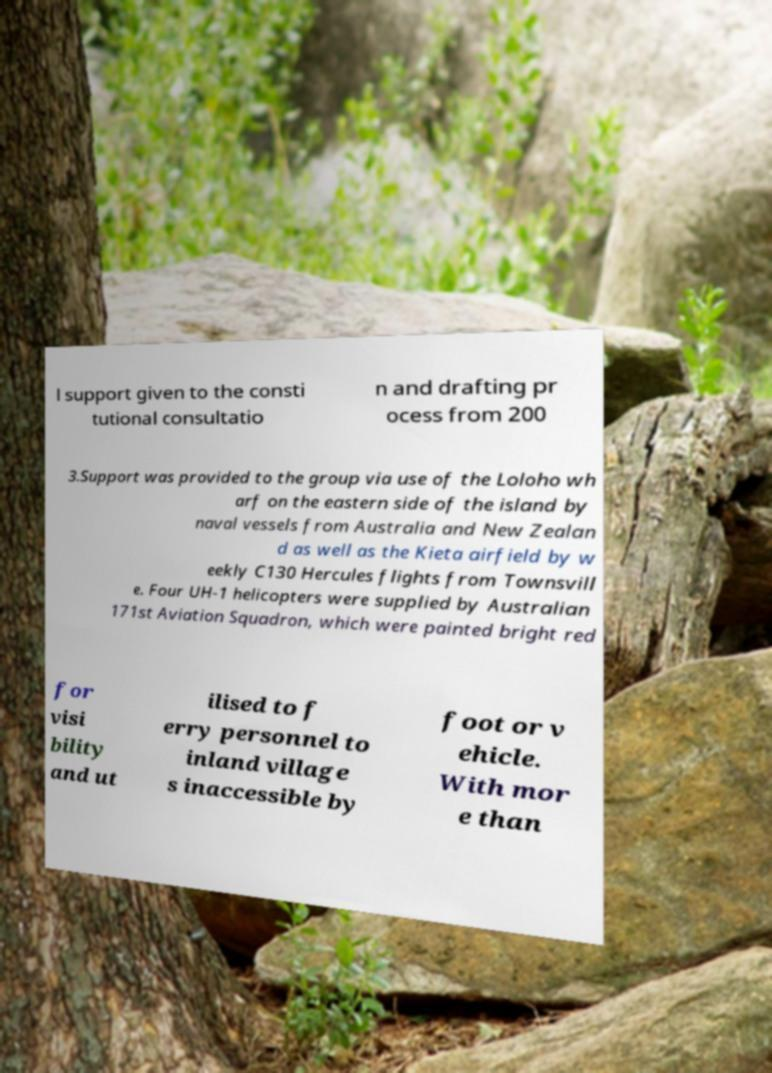Could you extract and type out the text from this image? l support given to the consti tutional consultatio n and drafting pr ocess from 200 3.Support was provided to the group via use of the Loloho wh arf on the eastern side of the island by naval vessels from Australia and New Zealan d as well as the Kieta airfield by w eekly C130 Hercules flights from Townsvill e. Four UH-1 helicopters were supplied by Australian 171st Aviation Squadron, which were painted bright red for visi bility and ut ilised to f erry personnel to inland village s inaccessible by foot or v ehicle. With mor e than 